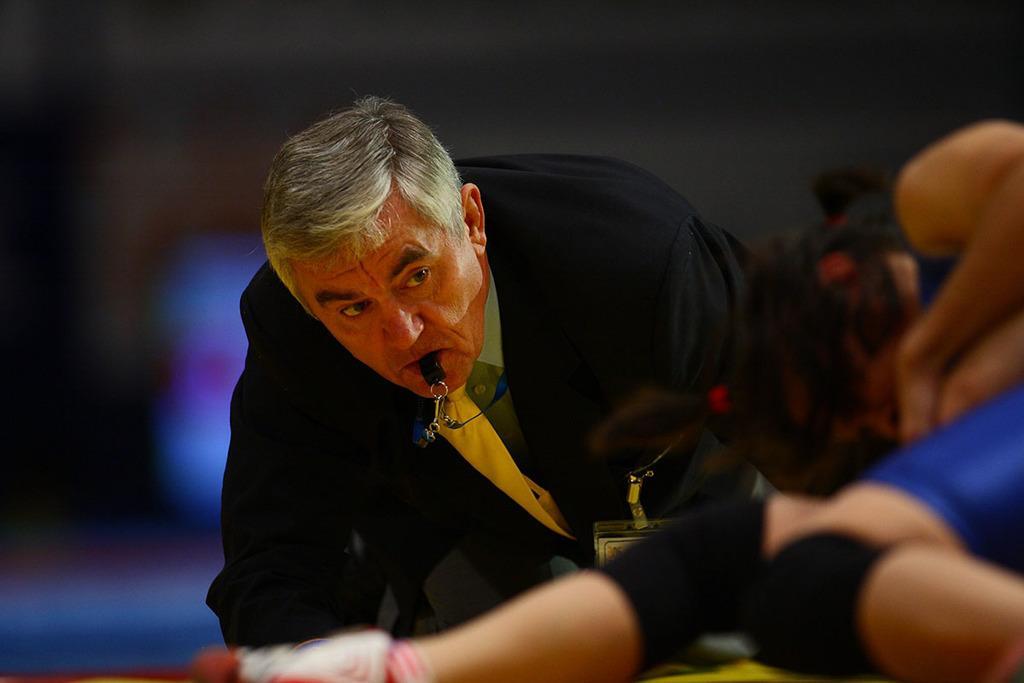In one or two sentences, can you explain what this image depicts? In this picture I can see a man with a whistle in his mouth, there is another person, and there is blur background. 